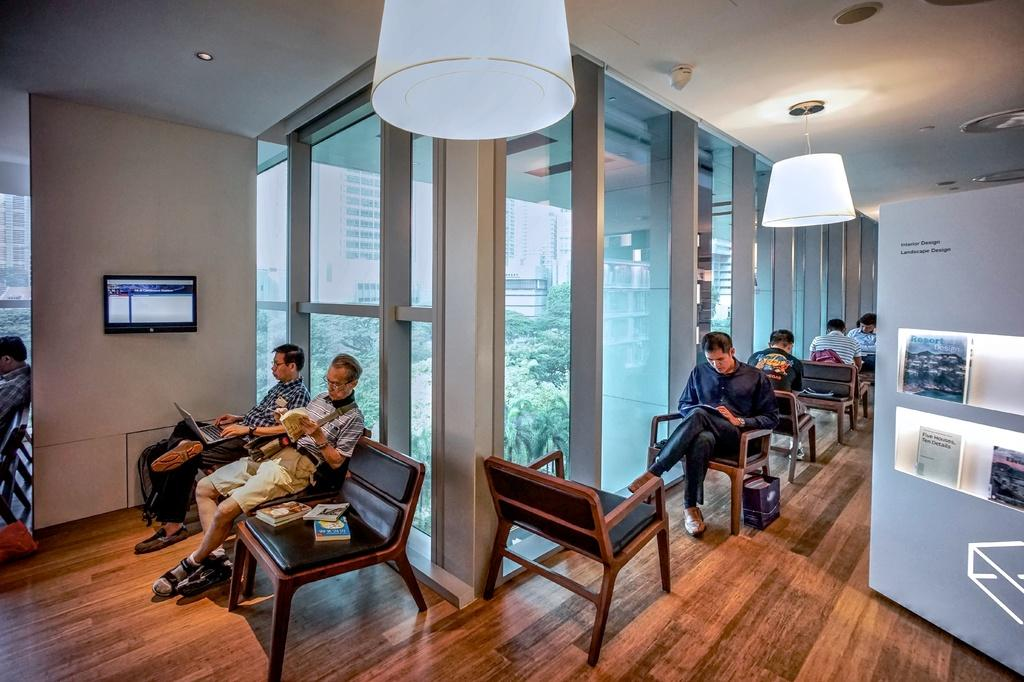What are the people in the image doing? The persons in the image are sitting on chairs. What can be seen in the background of the image? There is a glass, a wall, a monitor, and a banner in the background of the image. What type of grass can be seen growing on the scene in the image? There is no grass visible in the image, and the term "scene" is not applicable to the context of the image. 